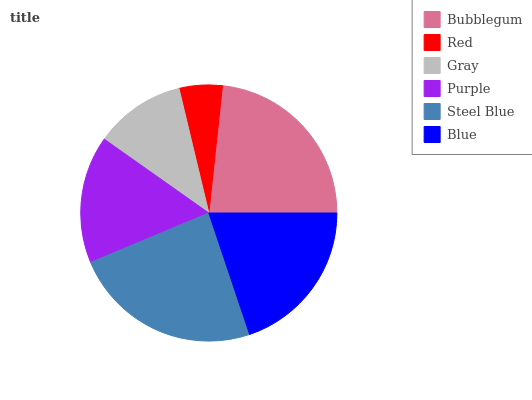Is Red the minimum?
Answer yes or no. Yes. Is Steel Blue the maximum?
Answer yes or no. Yes. Is Gray the minimum?
Answer yes or no. No. Is Gray the maximum?
Answer yes or no. No. Is Gray greater than Red?
Answer yes or no. Yes. Is Red less than Gray?
Answer yes or no. Yes. Is Red greater than Gray?
Answer yes or no. No. Is Gray less than Red?
Answer yes or no. No. Is Blue the high median?
Answer yes or no. Yes. Is Purple the low median?
Answer yes or no. Yes. Is Steel Blue the high median?
Answer yes or no. No. Is Red the low median?
Answer yes or no. No. 